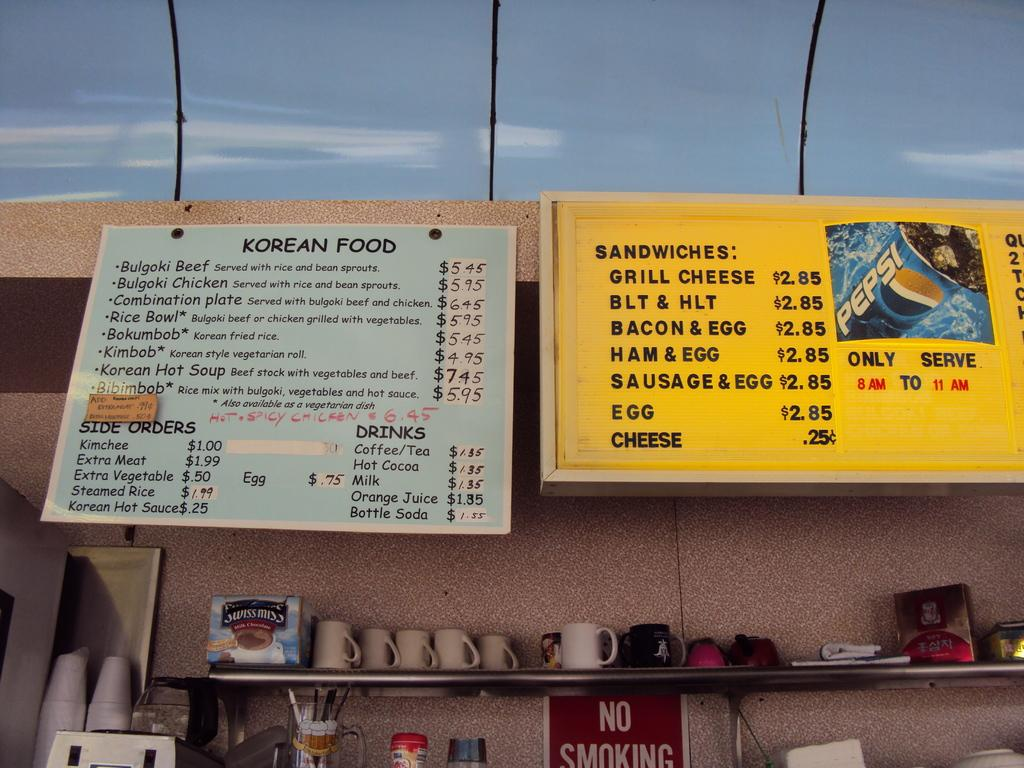Provide a one-sentence caption for the provided image. The menu signs on the wall list a variety of Korean foods as well as American classics like grilled cheese, BLT, and bacon and egg sandwich. 